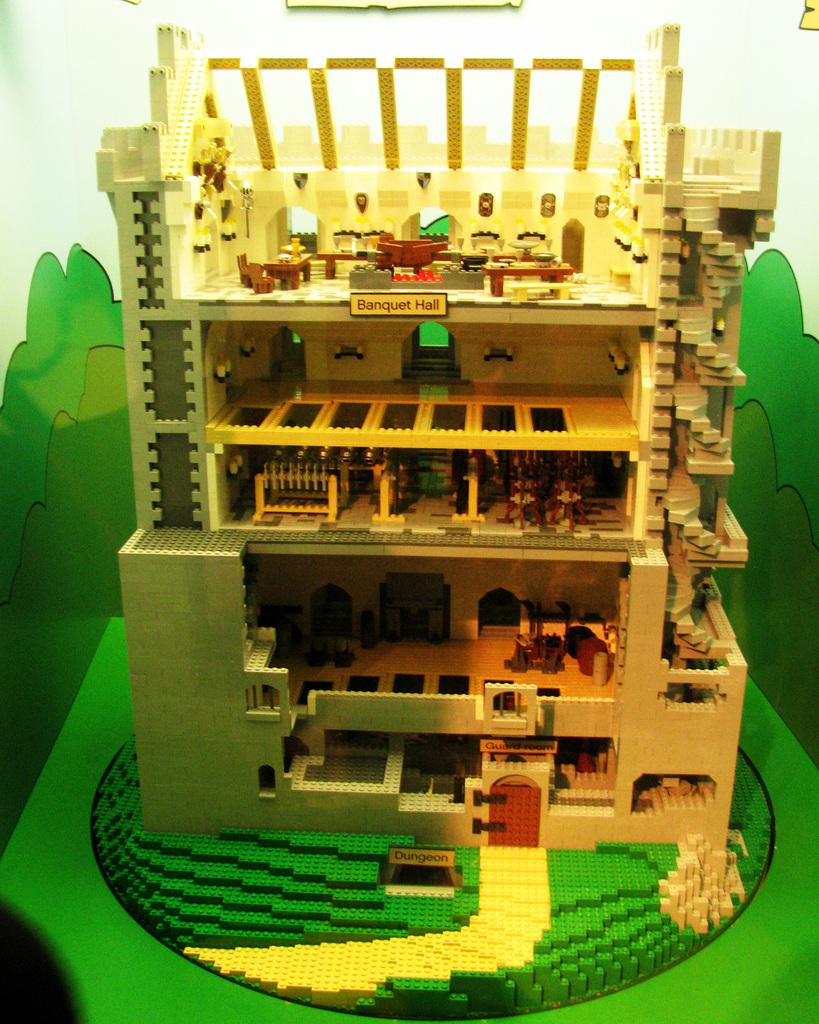What is the main subject of the image? The main subject of the image is a lego toy building. Where is the lego toy building located? The lego toy building is placed on a table. What can be seen behind the lego toy building? There is a wall visible behind the lego toy building. What type of honey is being served by the aunt in the image? There is no aunt or honey present in the image; it features a lego toy building on a table with a wall in the background. 